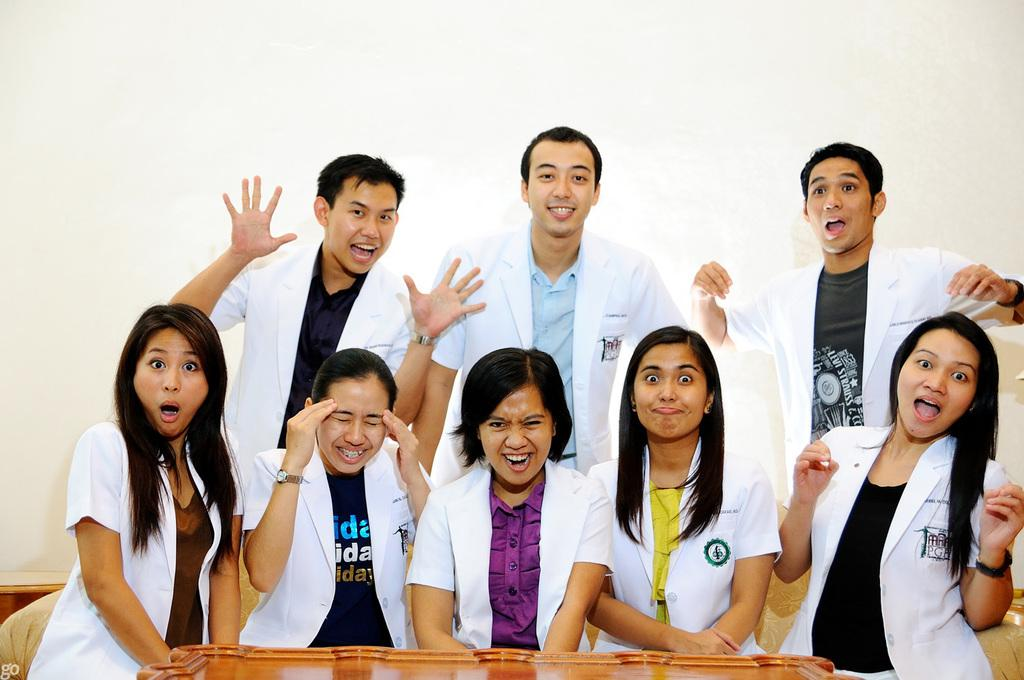What is the main subject of the image? The main subject of the image is a group of people. Can you describe the expressions or actions of the people in the image? Some people in the group are smiling, while others are watching. What type of object can be seen at the bottom of the image? There is a wooden object at the bottom of the image. What is the background of the image? There is a wall in the image. What type of hair can be seen on the leather object in the image? There is no hair or leather object present in the image. 